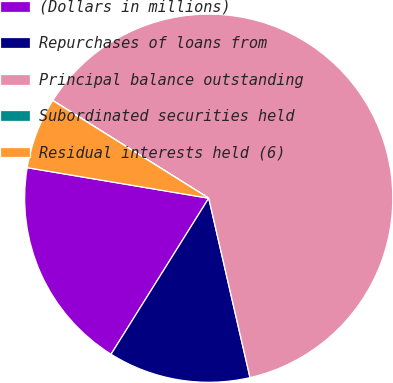Convert chart. <chart><loc_0><loc_0><loc_500><loc_500><pie_chart><fcel>(Dollars in millions)<fcel>Repurchases of loans from<fcel>Principal balance outstanding<fcel>Subordinated securities held<fcel>Residual interests held (6)<nl><fcel>18.75%<fcel>12.5%<fcel>62.49%<fcel>0.01%<fcel>6.25%<nl></chart> 